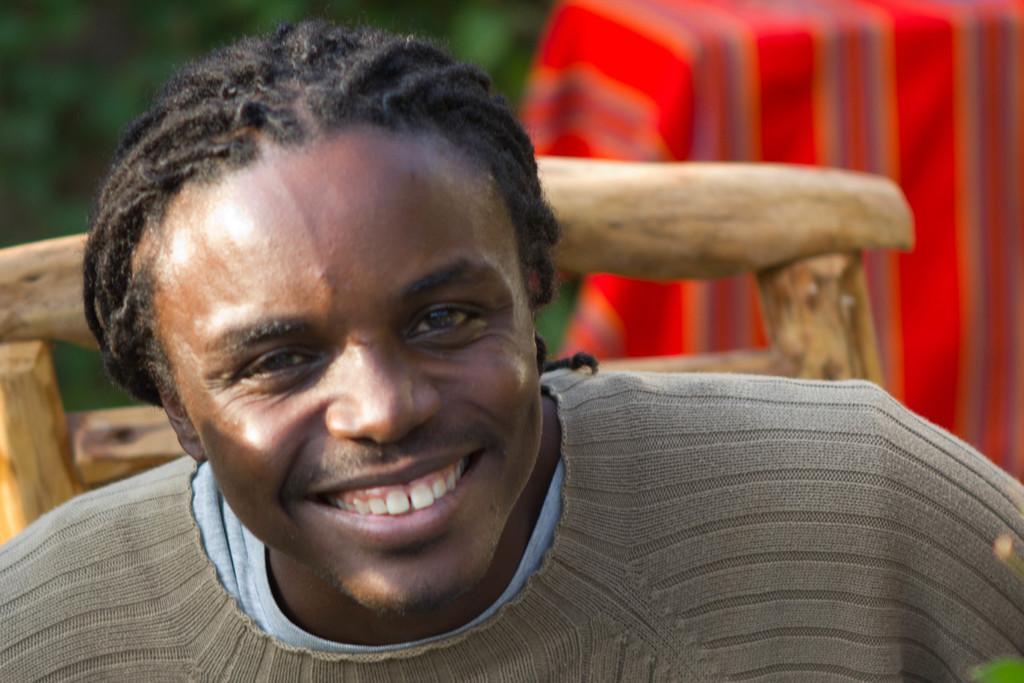Describe this image in one or two sentences. In this image I can see a man is smiling, he wore sweater. Behind him there is the wooden chair. 